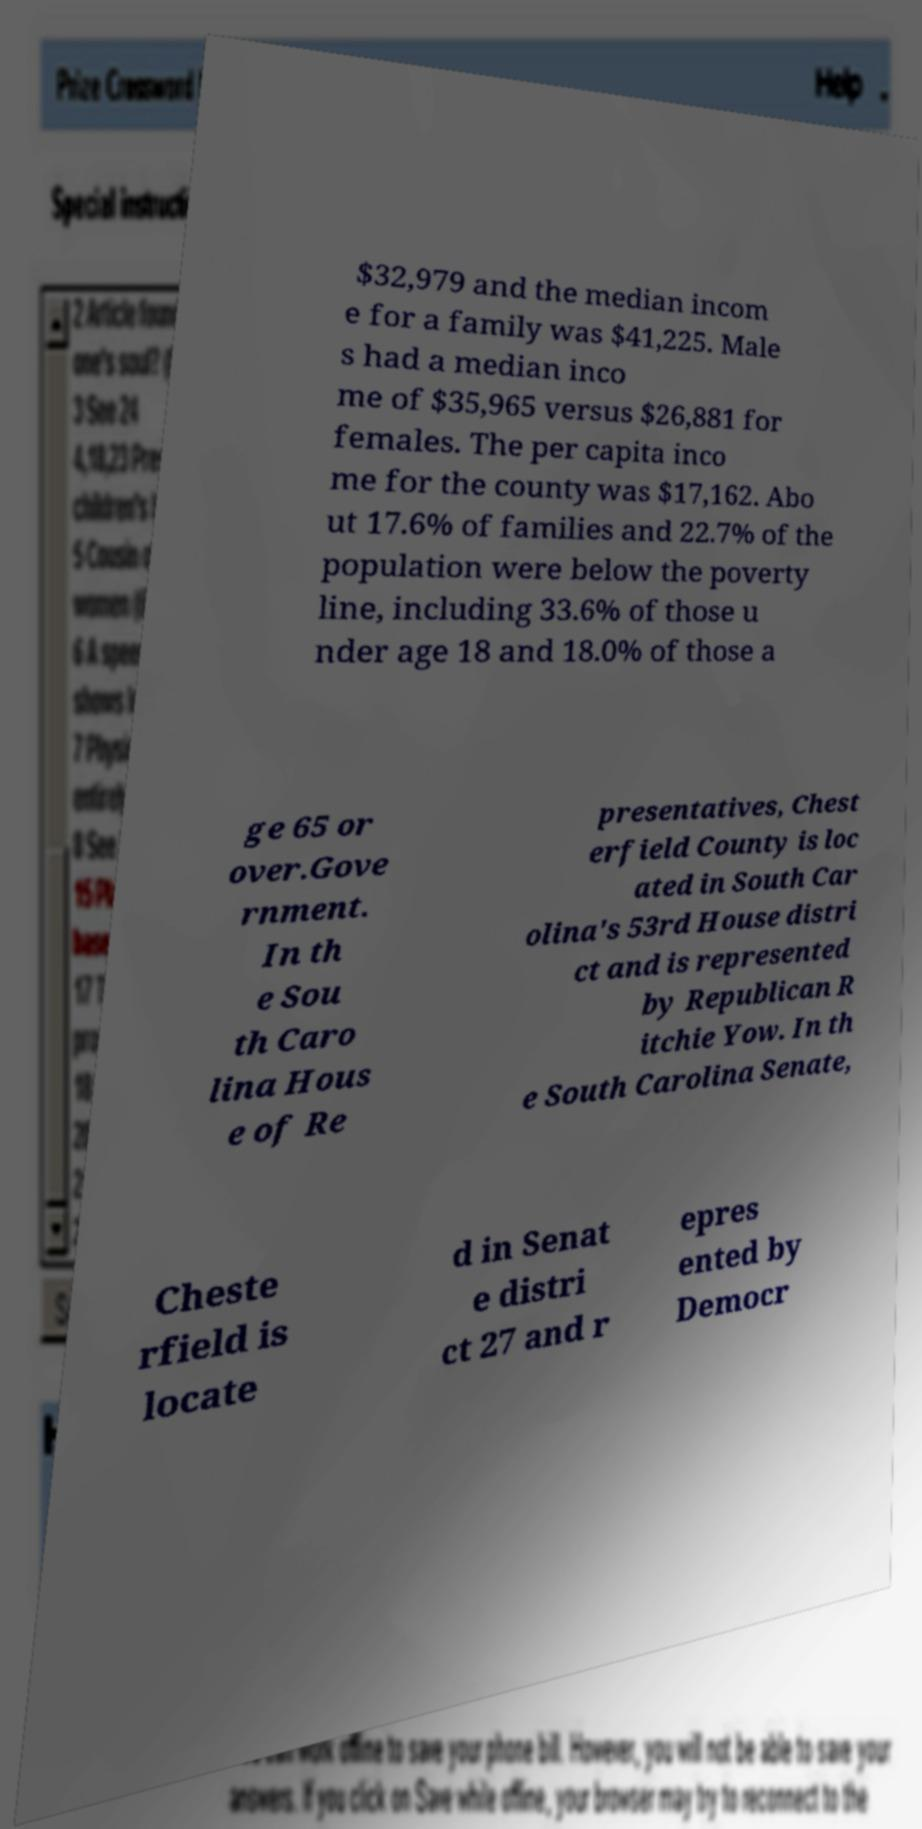Could you assist in decoding the text presented in this image and type it out clearly? $32,979 and the median incom e for a family was $41,225. Male s had a median inco me of $35,965 versus $26,881 for females. The per capita inco me for the county was $17,162. Abo ut 17.6% of families and 22.7% of the population were below the poverty line, including 33.6% of those u nder age 18 and 18.0% of those a ge 65 or over.Gove rnment. In th e Sou th Caro lina Hous e of Re presentatives, Chest erfield County is loc ated in South Car olina's 53rd House distri ct and is represented by Republican R itchie Yow. In th e South Carolina Senate, Cheste rfield is locate d in Senat e distri ct 27 and r epres ented by Democr 